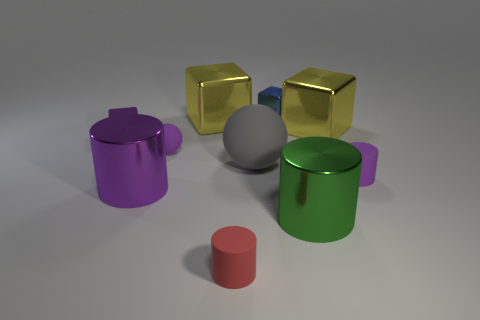Is the tiny cylinder behind the large purple cylinder made of the same material as the tiny purple thing left of the tiny matte sphere?
Offer a very short reply. No. Is there another sphere of the same color as the large matte sphere?
Make the answer very short. No. What color is the sphere that is the same size as the purple cube?
Give a very brief answer. Purple. There is a tiny metallic cube behind the purple block; does it have the same color as the big rubber sphere?
Offer a very short reply. No. Is there a big green thing made of the same material as the red thing?
Your answer should be very brief. No. What is the shape of the tiny rubber object that is the same color as the tiny matte sphere?
Provide a succinct answer. Cylinder. Is the number of tiny rubber things in front of the small red rubber cylinder less than the number of blue rubber balls?
Provide a short and direct response. No. There is a purple cylinder right of the green object; does it have the same size as the tiny purple shiny cube?
Your answer should be compact. Yes. What number of purple shiny things are the same shape as the tiny blue thing?
Provide a short and direct response. 1. There is a purple block that is made of the same material as the green object; what is its size?
Make the answer very short. Small. 